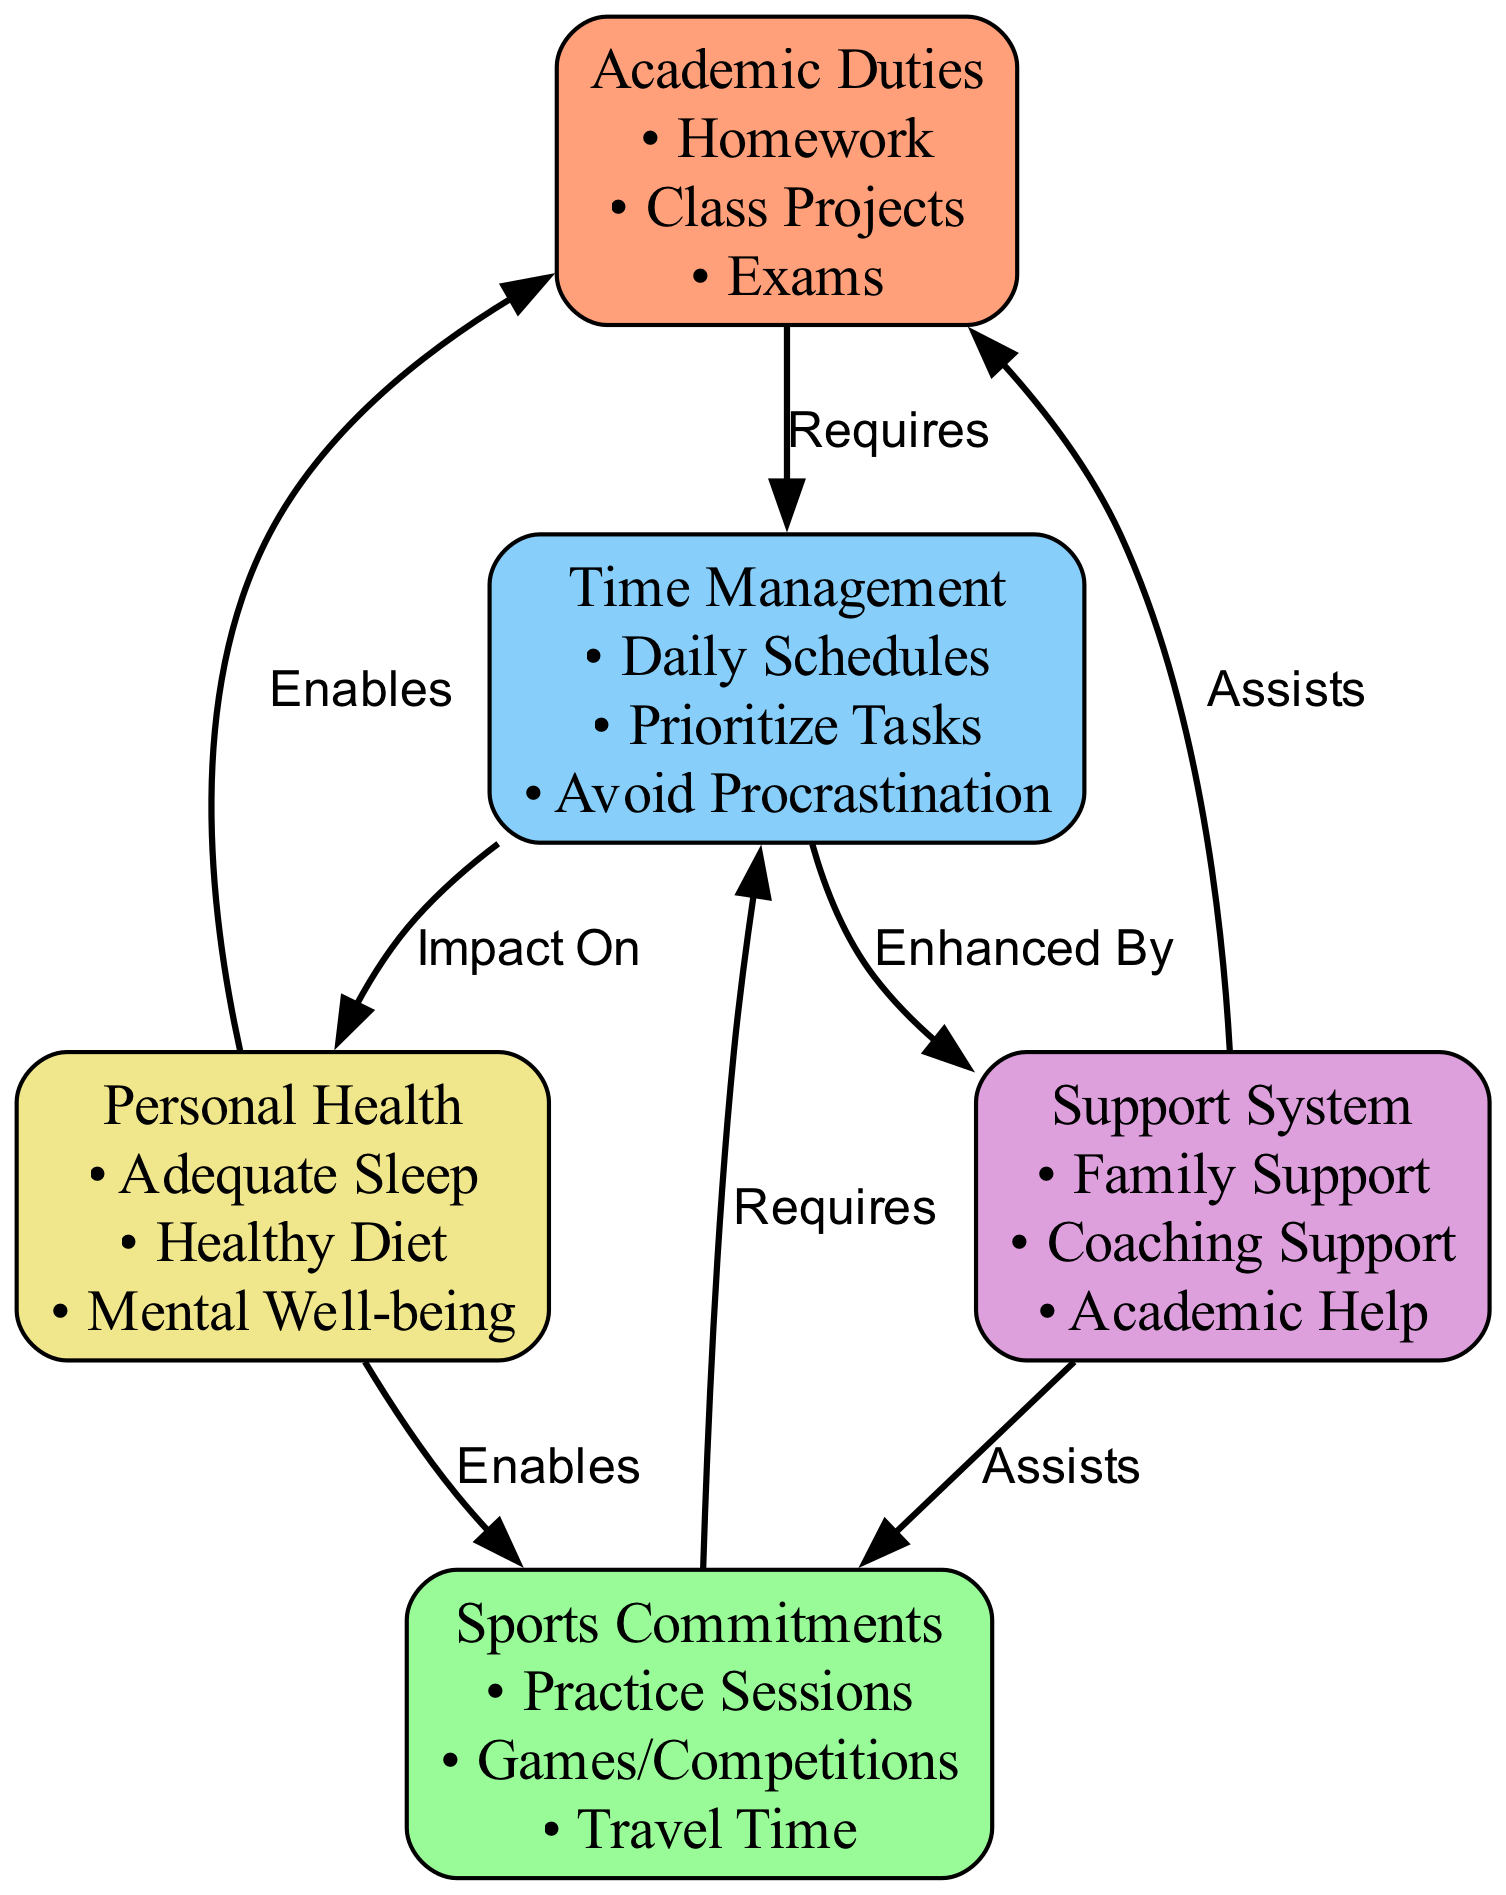What nodes represent academic responsibilities? The nodes representing academic responsibilities are labeled "Academic Duties" and detail tasks such as Homework, Class Projects, and Exams.
Answer: Academic Duties How many nodes are in the diagram? The diagram contains a total of five nodes: Academic Duties, Sports Commitments, Time Management, Support System, and Personal Health.
Answer: 5 What are the components of Sports Commitments? The components under Sports Commitments include Practice Sessions, Games/Competitions, and Travel Time.
Answer: Practice Sessions, Games/Competitions, Travel Time Which node is impacted by Time Management? The nodes that are impacted by Time Management are Support System and Personal Health, indicating that effective time management helps these areas.
Answer: Support System, Personal Health What does the Support System assist with? The Support System assists with both Academic Duties and Sports Commitments, providing help in balancing these responsibilities.
Answer: Academic Duties, Sports Commitments If personal health is enabled, what are the related areas? The areas enabled by Personal Health are Academic Duties and Sports Commitments, showing that good health supports both academic and athletic performance.
Answer: Academic Duties, Sports Commitments What type of relationship exists between Academic Duties and Time Management? The relationship is that Academic Duties requires Time Management, indicating that managing time is necessary for fulfilling academic responsibilities.
Answer: Requires What is impacted by Time Management according to the diagram? Time Management has an impact on both the Support System and Personal Health, suggesting that managing one’s time can enhance support received and health.
Answer: Support System, Personal Health How does the Support System enhance time management? The Support System enhances Time Management by providing additional resources and assistance that can help youth athletes better organize their schedules.
Answer: Enhanced By 